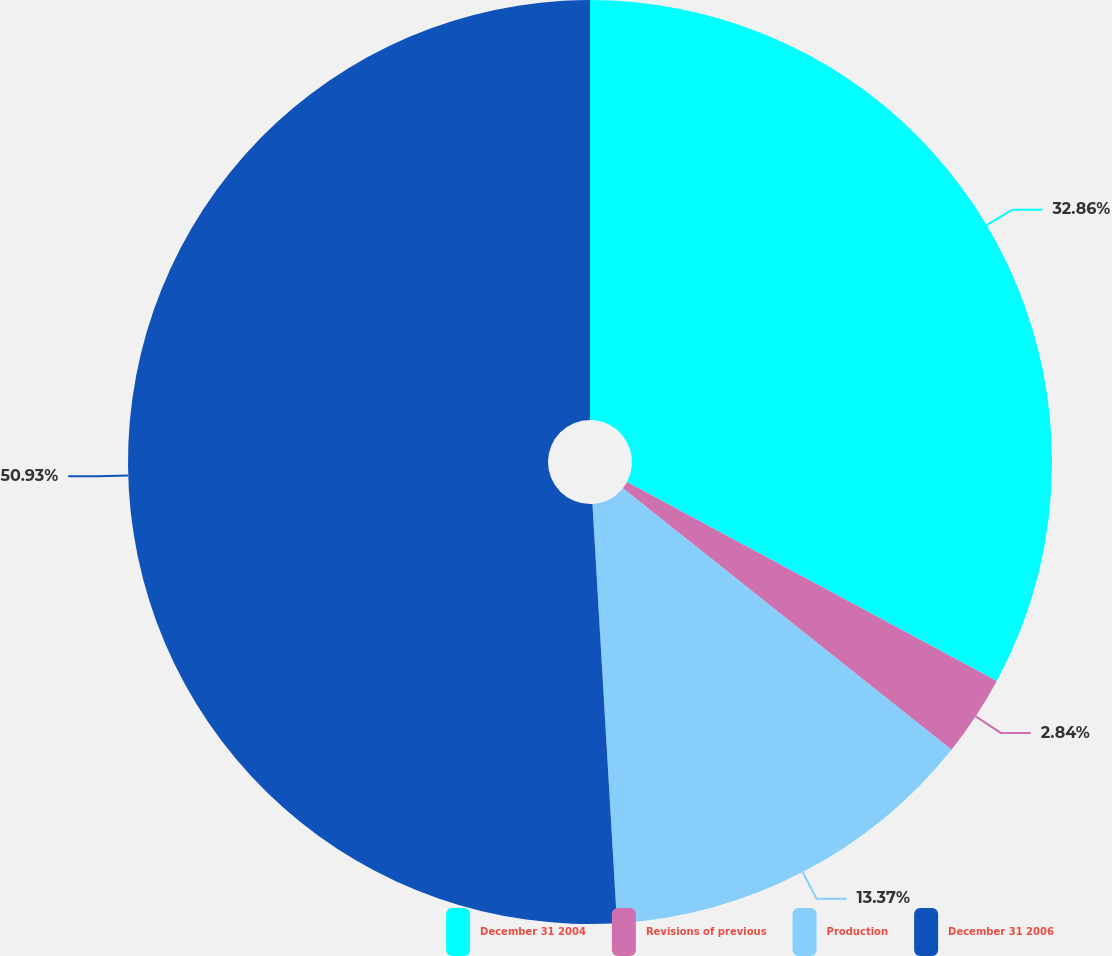<chart> <loc_0><loc_0><loc_500><loc_500><pie_chart><fcel>December 31 2004<fcel>Revisions of previous<fcel>Production<fcel>December 31 2006<nl><fcel>32.86%<fcel>2.84%<fcel>13.37%<fcel>50.93%<nl></chart> 